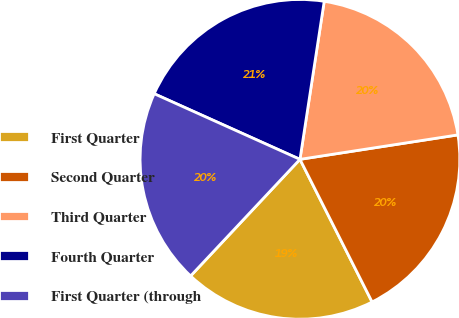<chart> <loc_0><loc_0><loc_500><loc_500><pie_chart><fcel>First Quarter<fcel>Second Quarter<fcel>Third Quarter<fcel>Fourth Quarter<fcel>First Quarter (through<nl><fcel>19.44%<fcel>19.99%<fcel>20.13%<fcel>20.69%<fcel>19.74%<nl></chart> 